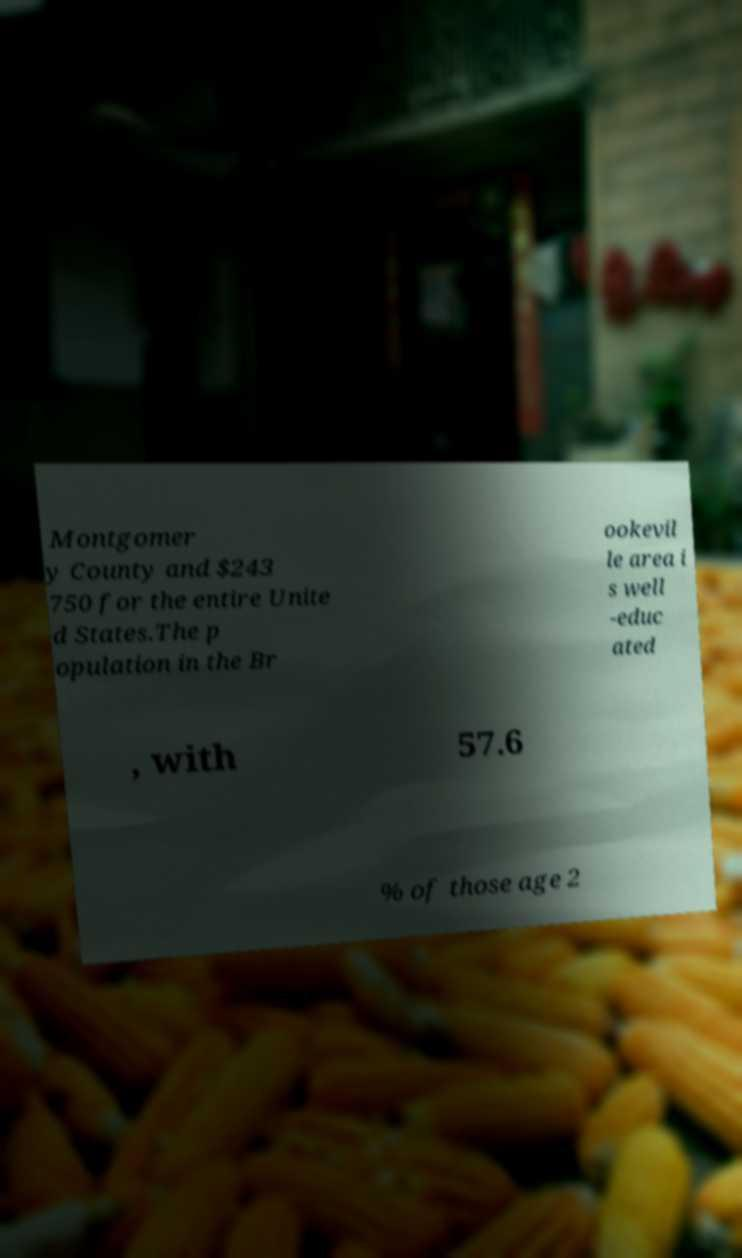Can you read and provide the text displayed in the image?This photo seems to have some interesting text. Can you extract and type it out for me? Montgomer y County and $243 750 for the entire Unite d States.The p opulation in the Br ookevil le area i s well -educ ated , with 57.6 % of those age 2 